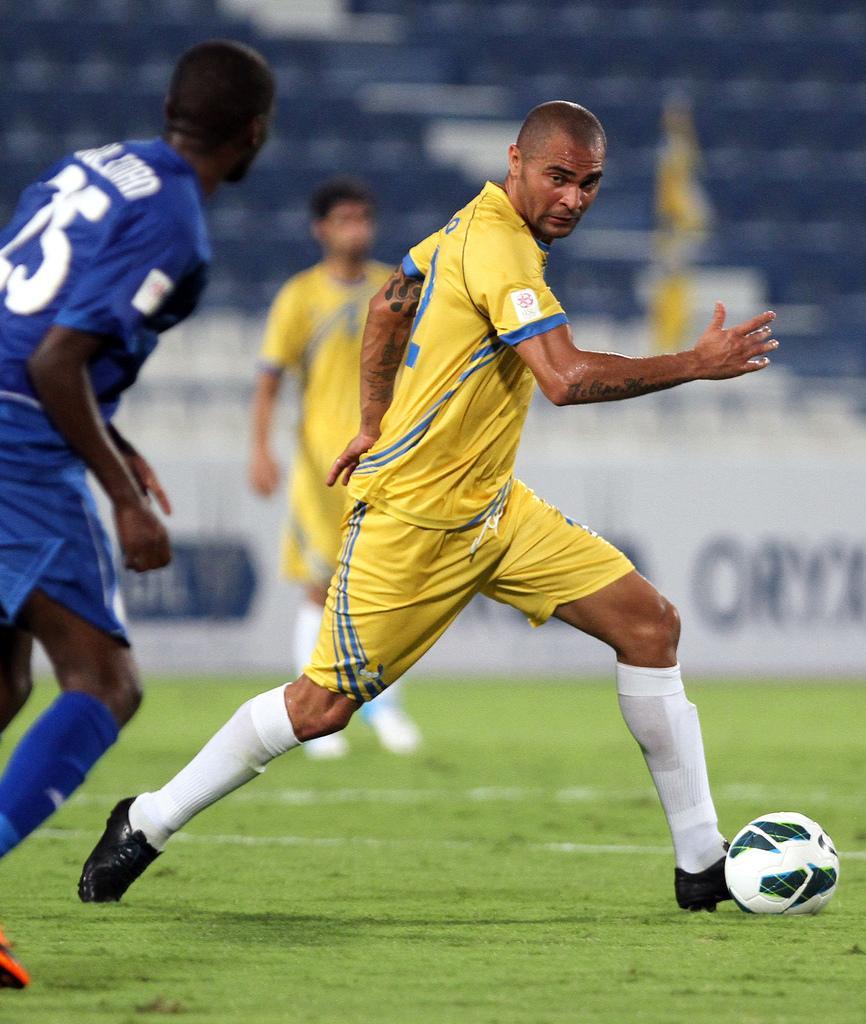How would you summarize this image in a sentence or two? This image consists of three person. Out of which one person is running towards the ball, who is wearing yellow color jersey. In the left, a person who is wearing blue color jersey, is running on the ground. In the middle, a person is standing who is wearing a yellow color jersey. In the background seats are visible and board is visible. At the bottom grass is visible. This image is taken during day time on the ground. 